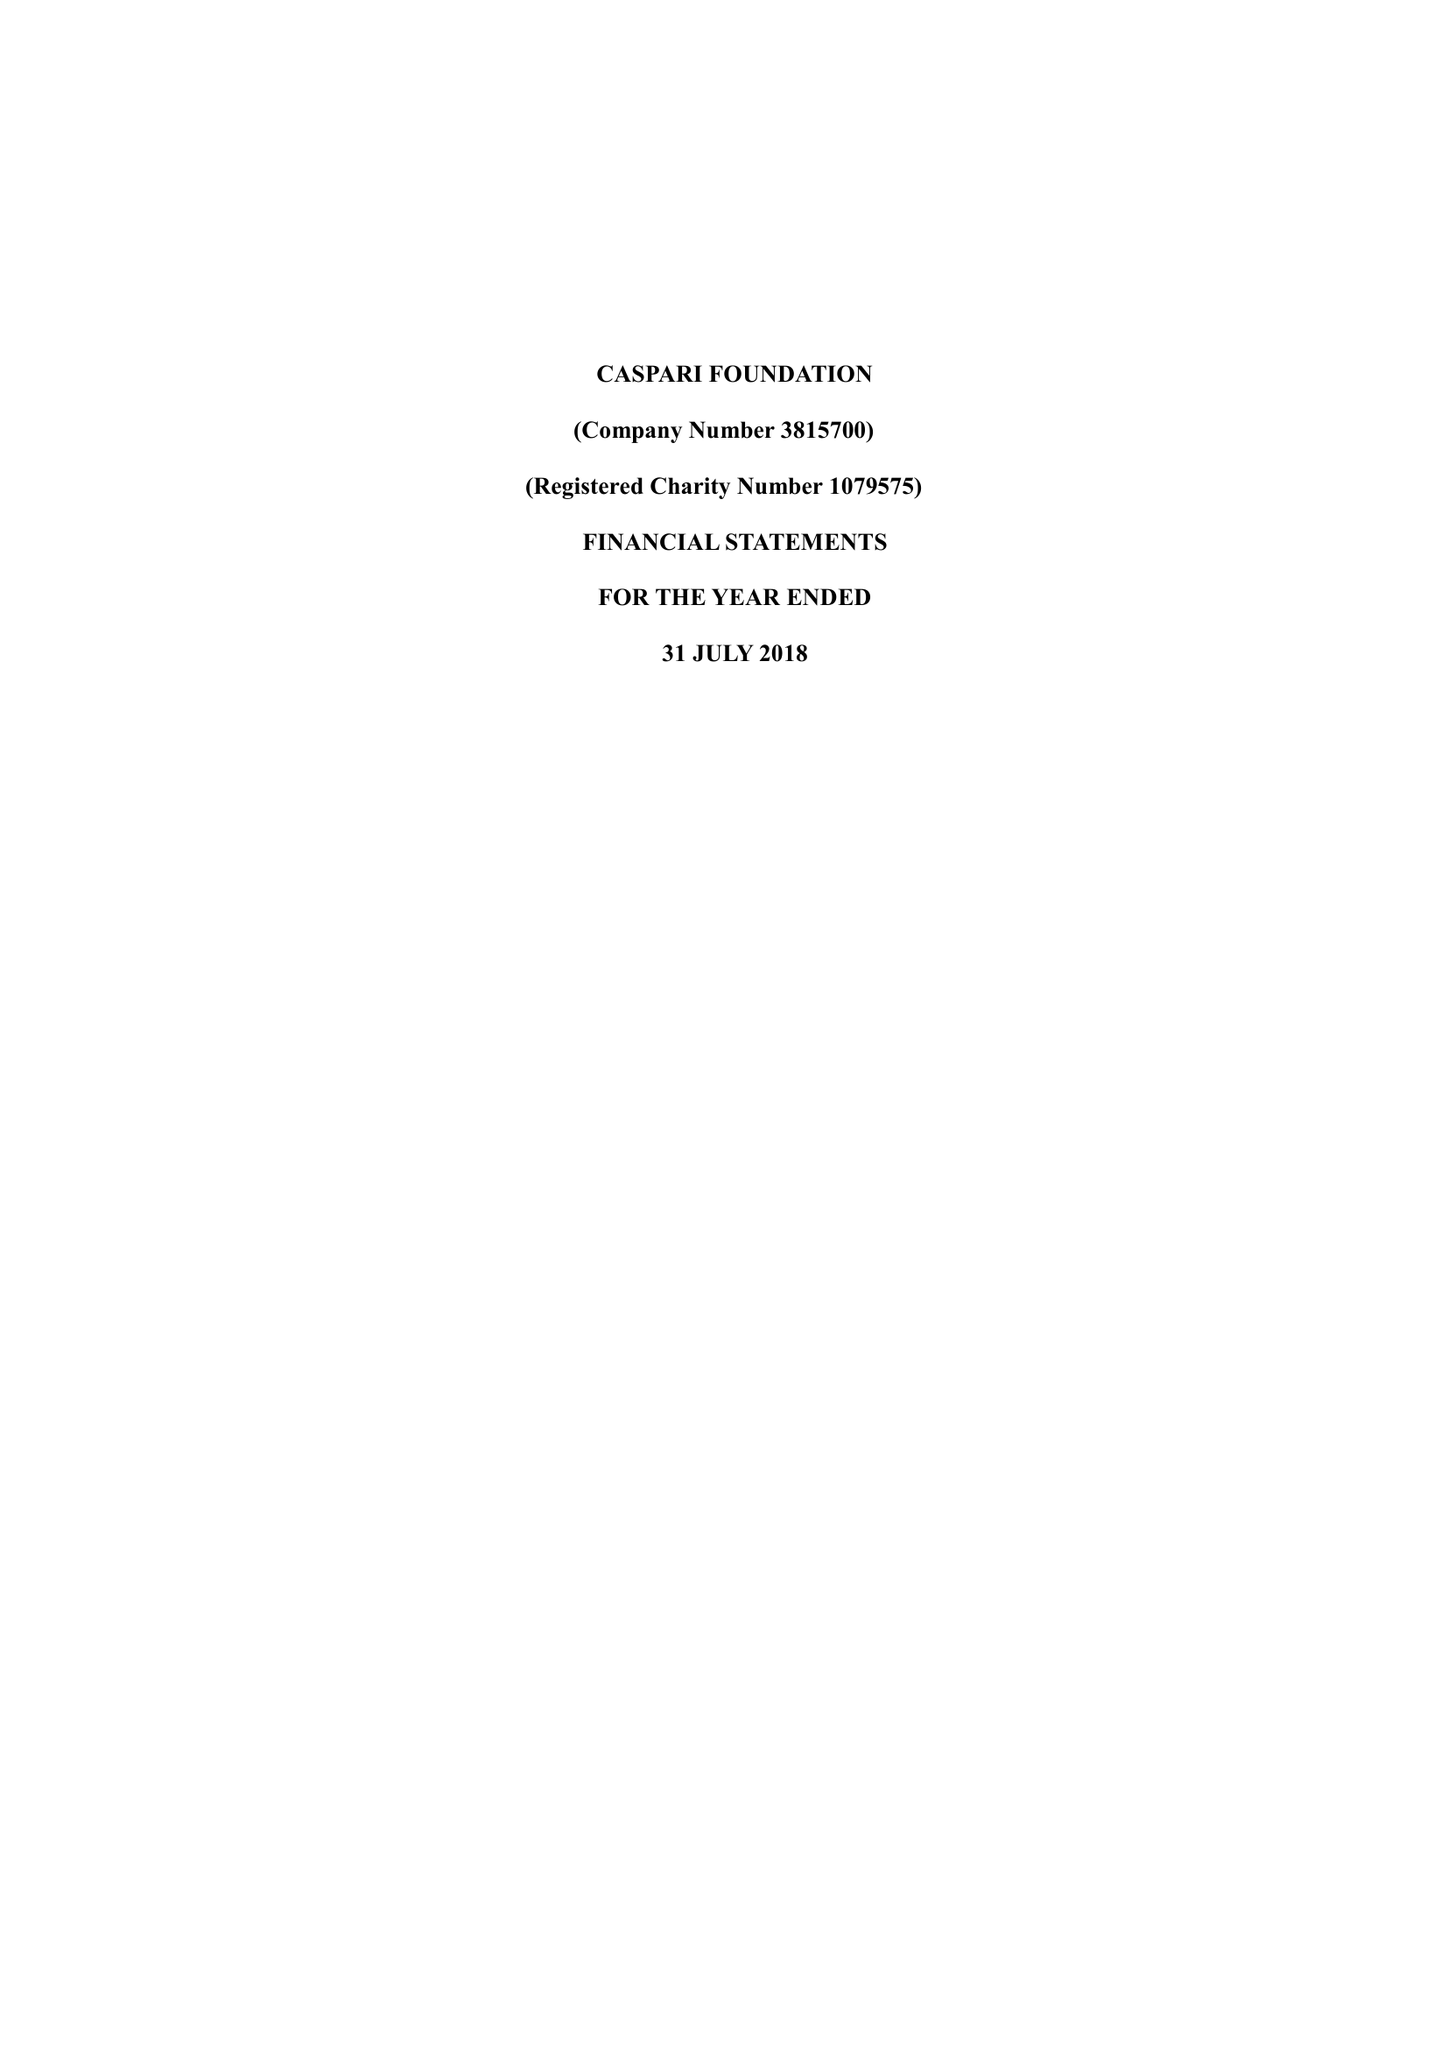What is the value for the address__post_town?
Answer the question using a single word or phrase. LONDON 